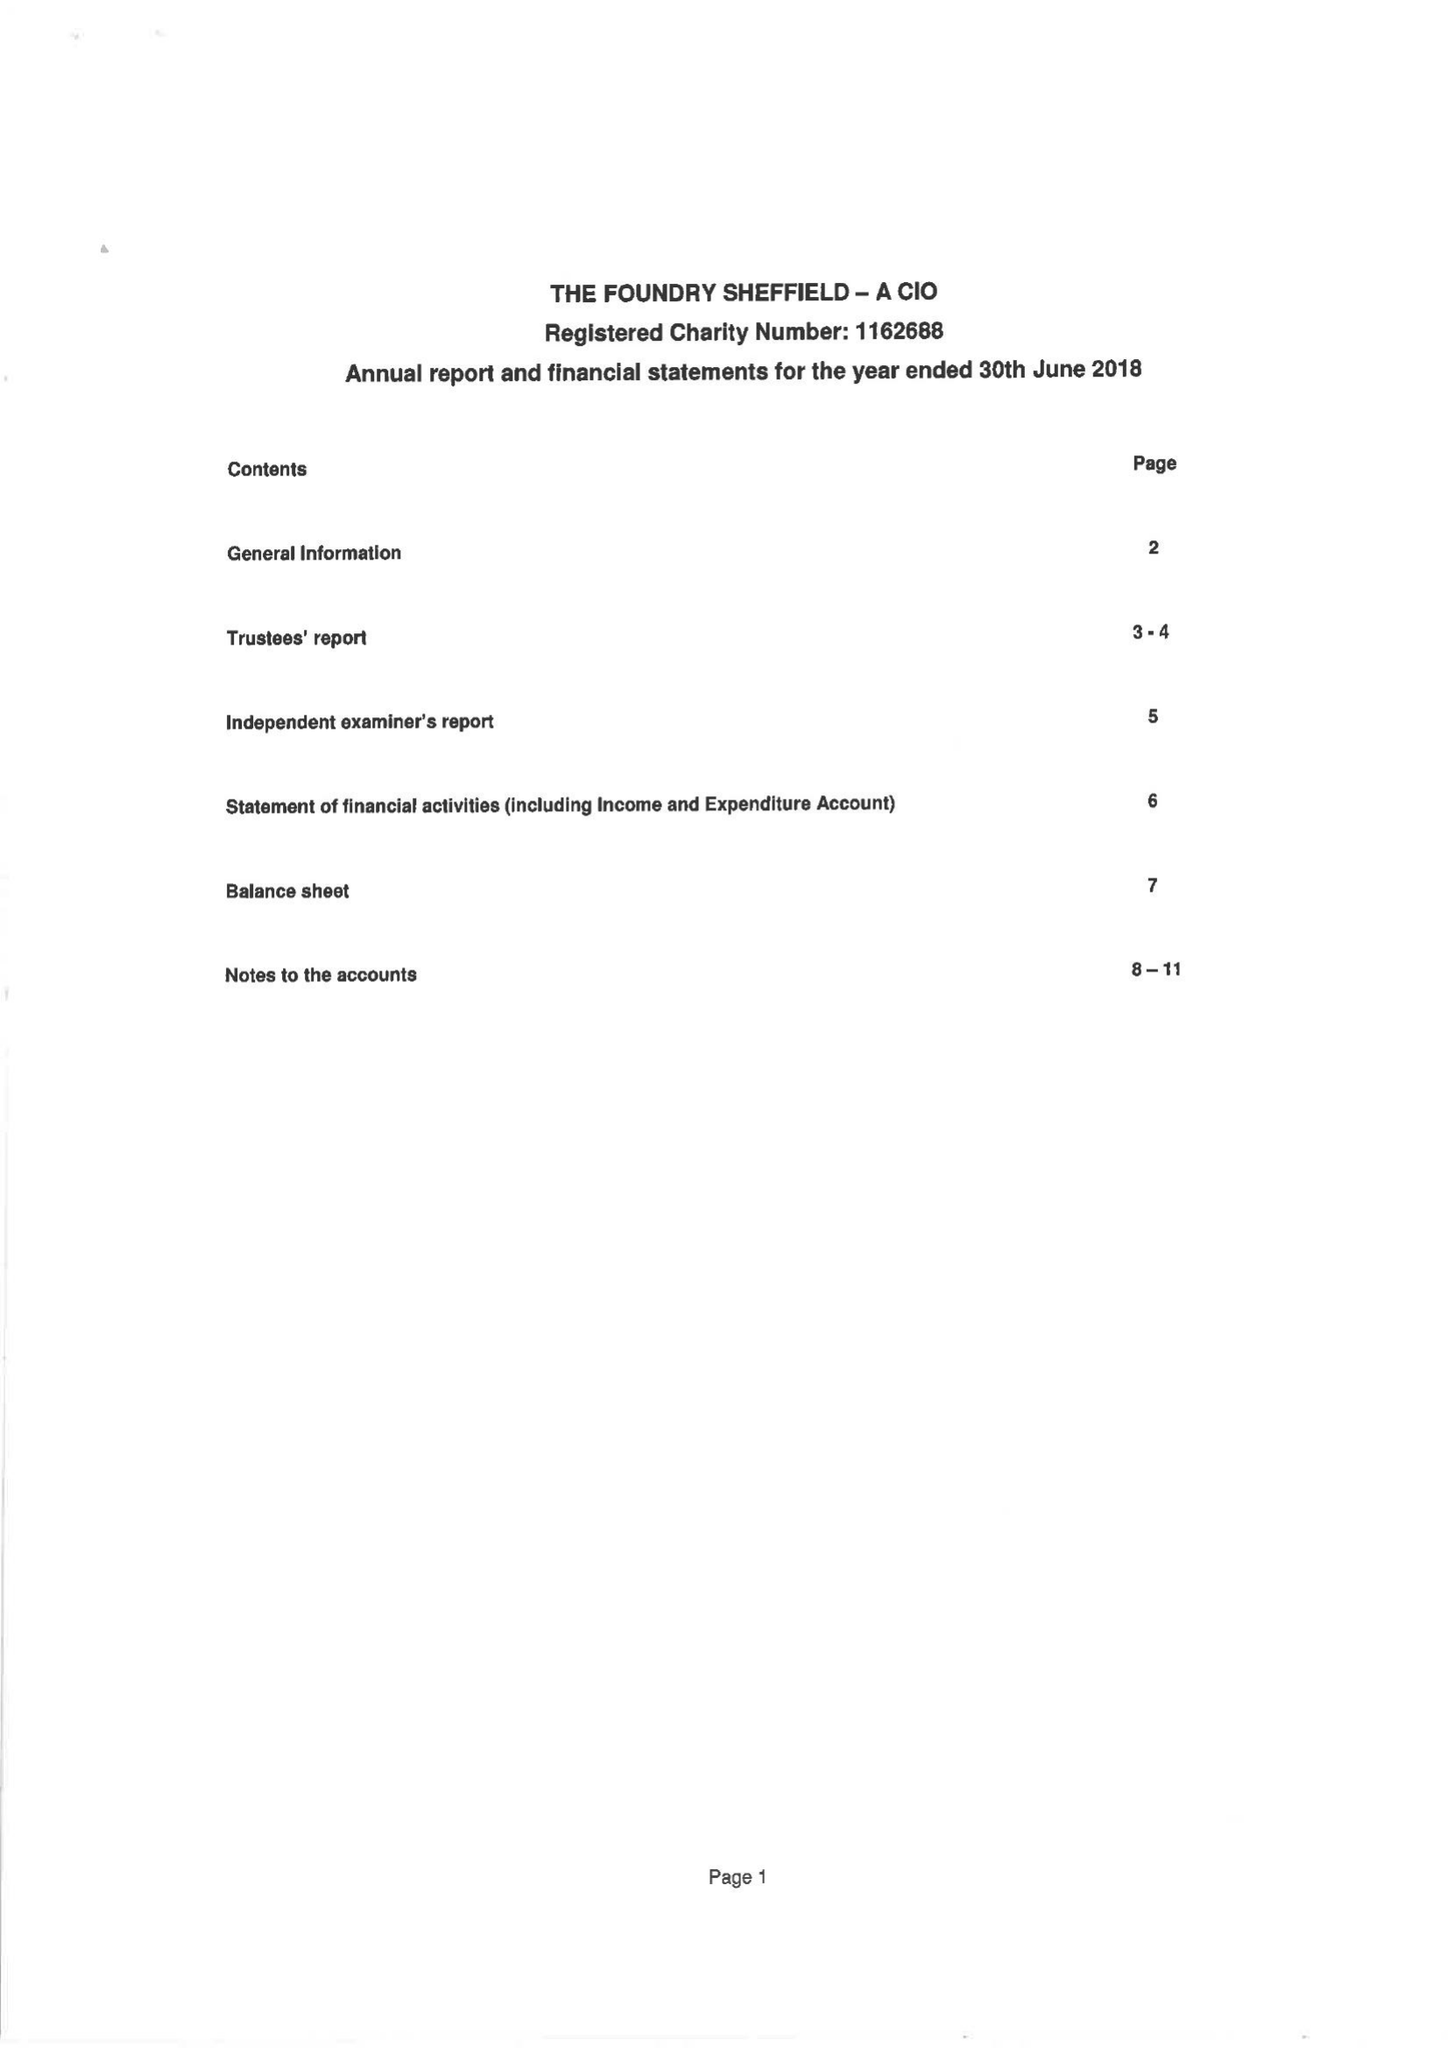What is the value for the address__street_line?
Answer the question using a single word or phrase. NORFOLK STREET 